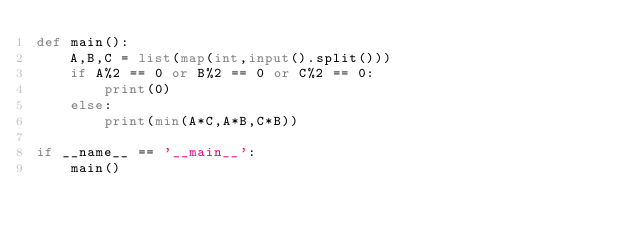Convert code to text. <code><loc_0><loc_0><loc_500><loc_500><_Python_>def main():
    A,B,C = list(map(int,input().split()))
    if A%2 == 0 or B%2 == 0 or C%2 == 0:
        print(0)
    else:
        print(min(A*C,A*B,C*B))

if __name__ == '__main__':
    main()</code> 